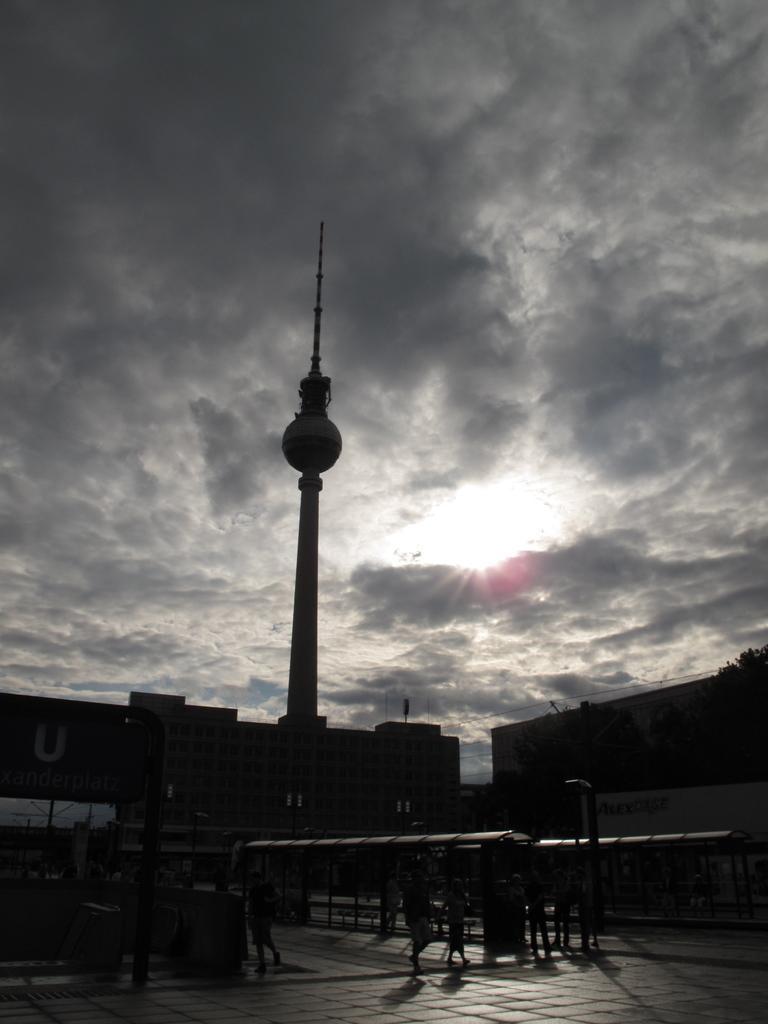How would you summarize this image in a sentence or two? In this picture there are buildings and trees and there is a tower and there are group of people walking. On the left side of the image there is text on the board. At the top there is sky and there are clouds and there is a sun. 